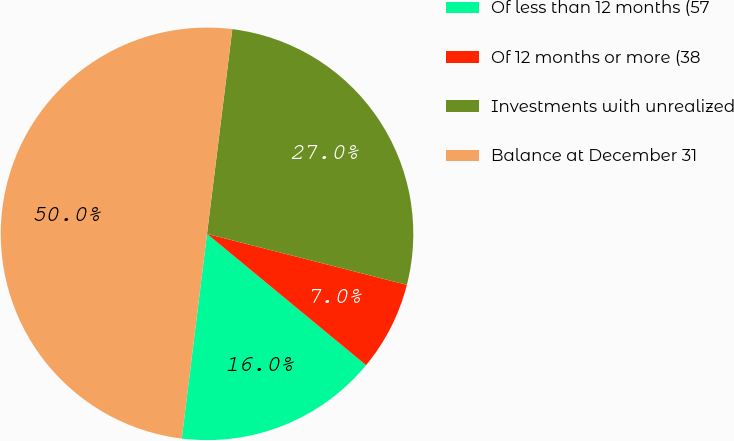<chart> <loc_0><loc_0><loc_500><loc_500><pie_chart><fcel>Of less than 12 months (57<fcel>Of 12 months or more (38<fcel>Investments with unrealized<fcel>Balance at December 31<nl><fcel>15.97%<fcel>7.01%<fcel>27.02%<fcel>50.0%<nl></chart> 